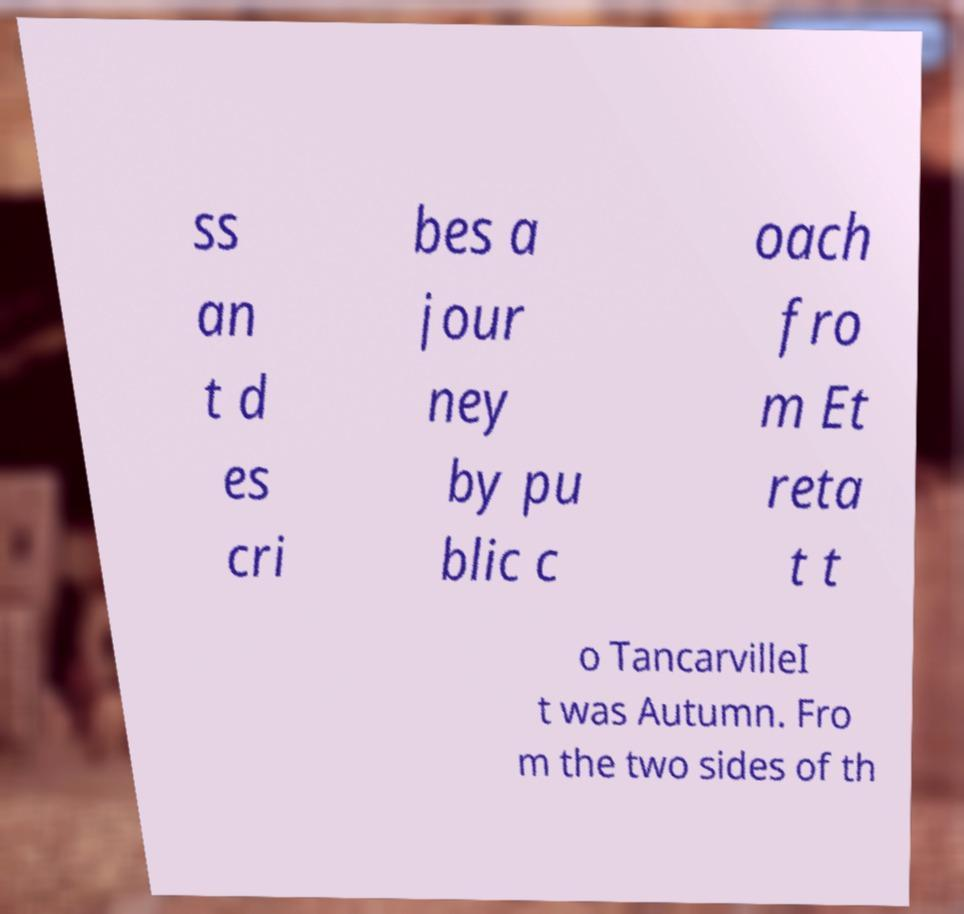Please read and relay the text visible in this image. What does it say? ss an t d es cri bes a jour ney by pu blic c oach fro m Et reta t t o TancarvilleI t was Autumn. Fro m the two sides of th 